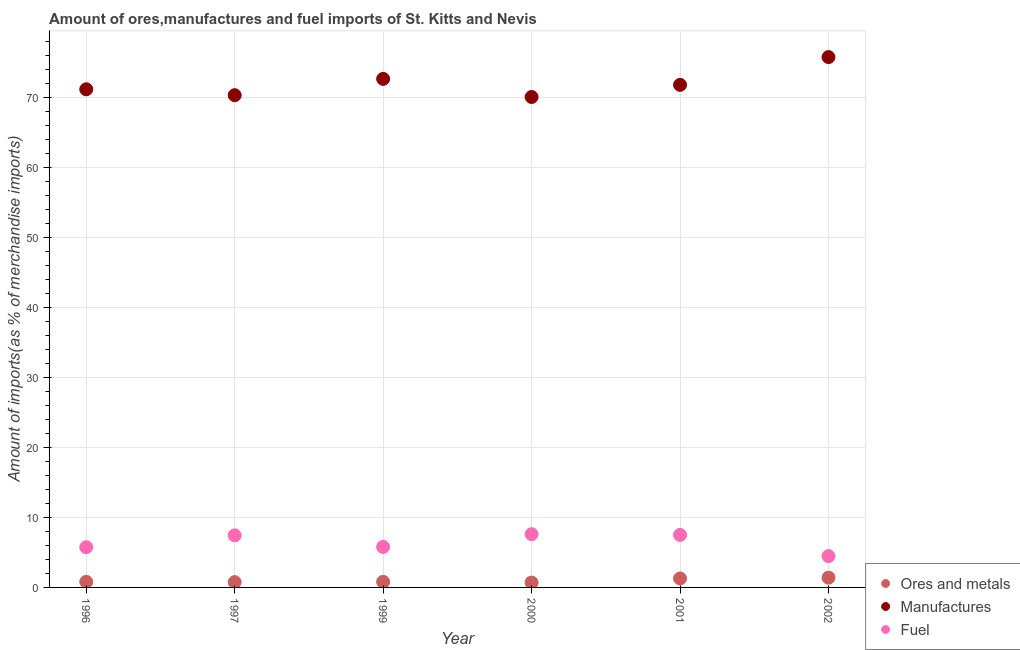How many different coloured dotlines are there?
Your answer should be very brief. 3. Is the number of dotlines equal to the number of legend labels?
Give a very brief answer. Yes. What is the percentage of ores and metals imports in 2002?
Ensure brevity in your answer.  1.39. Across all years, what is the maximum percentage of fuel imports?
Your answer should be very brief. 7.61. Across all years, what is the minimum percentage of ores and metals imports?
Your answer should be very brief. 0.69. In which year was the percentage of ores and metals imports maximum?
Offer a very short reply. 2002. In which year was the percentage of manufactures imports minimum?
Ensure brevity in your answer.  2000. What is the total percentage of ores and metals imports in the graph?
Your response must be concise. 5.73. What is the difference between the percentage of fuel imports in 2001 and that in 2002?
Your answer should be compact. 3.04. What is the difference between the percentage of fuel imports in 1997 and the percentage of manufactures imports in 2000?
Your answer should be compact. -62.66. What is the average percentage of manufactures imports per year?
Offer a terse response. 72.01. In the year 2002, what is the difference between the percentage of manufactures imports and percentage of fuel imports?
Keep it short and to the point. 71.34. In how many years, is the percentage of manufactures imports greater than 76 %?
Provide a succinct answer. 0. What is the ratio of the percentage of manufactures imports in 2001 to that in 2002?
Make the answer very short. 0.95. What is the difference between the highest and the second highest percentage of ores and metals imports?
Provide a succinct answer. 0.11. What is the difference between the highest and the lowest percentage of ores and metals imports?
Provide a succinct answer. 0.7. In how many years, is the percentage of manufactures imports greater than the average percentage of manufactures imports taken over all years?
Provide a short and direct response. 2. Does the percentage of manufactures imports monotonically increase over the years?
Keep it short and to the point. No. How many dotlines are there?
Your response must be concise. 3. How many legend labels are there?
Offer a terse response. 3. How are the legend labels stacked?
Provide a succinct answer. Vertical. What is the title of the graph?
Make the answer very short. Amount of ores,manufactures and fuel imports of St. Kitts and Nevis. Does "Self-employed" appear as one of the legend labels in the graph?
Provide a succinct answer. No. What is the label or title of the X-axis?
Provide a short and direct response. Year. What is the label or title of the Y-axis?
Offer a terse response. Amount of imports(as % of merchandise imports). What is the Amount of imports(as % of merchandise imports) of Ores and metals in 1996?
Your answer should be very brief. 0.8. What is the Amount of imports(as % of merchandise imports) in Manufactures in 1996?
Your answer should be very brief. 71.21. What is the Amount of imports(as % of merchandise imports) of Fuel in 1996?
Ensure brevity in your answer.  5.75. What is the Amount of imports(as % of merchandise imports) in Ores and metals in 1997?
Ensure brevity in your answer.  0.76. What is the Amount of imports(as % of merchandise imports) in Manufactures in 1997?
Offer a very short reply. 70.37. What is the Amount of imports(as % of merchandise imports) in Fuel in 1997?
Provide a short and direct response. 7.45. What is the Amount of imports(as % of merchandise imports) in Ores and metals in 1999?
Your response must be concise. 0.8. What is the Amount of imports(as % of merchandise imports) of Manufactures in 1999?
Give a very brief answer. 72.7. What is the Amount of imports(as % of merchandise imports) of Fuel in 1999?
Ensure brevity in your answer.  5.79. What is the Amount of imports(as % of merchandise imports) of Ores and metals in 2000?
Provide a succinct answer. 0.69. What is the Amount of imports(as % of merchandise imports) in Manufactures in 2000?
Offer a terse response. 70.11. What is the Amount of imports(as % of merchandise imports) in Fuel in 2000?
Provide a succinct answer. 7.61. What is the Amount of imports(as % of merchandise imports) in Ores and metals in 2001?
Make the answer very short. 1.28. What is the Amount of imports(as % of merchandise imports) in Manufactures in 2001?
Keep it short and to the point. 71.85. What is the Amount of imports(as % of merchandise imports) of Fuel in 2001?
Ensure brevity in your answer.  7.51. What is the Amount of imports(as % of merchandise imports) of Ores and metals in 2002?
Ensure brevity in your answer.  1.39. What is the Amount of imports(as % of merchandise imports) in Manufactures in 2002?
Give a very brief answer. 75.82. What is the Amount of imports(as % of merchandise imports) in Fuel in 2002?
Your answer should be compact. 4.47. Across all years, what is the maximum Amount of imports(as % of merchandise imports) of Ores and metals?
Give a very brief answer. 1.39. Across all years, what is the maximum Amount of imports(as % of merchandise imports) in Manufactures?
Ensure brevity in your answer.  75.82. Across all years, what is the maximum Amount of imports(as % of merchandise imports) of Fuel?
Provide a succinct answer. 7.61. Across all years, what is the minimum Amount of imports(as % of merchandise imports) of Ores and metals?
Your answer should be compact. 0.69. Across all years, what is the minimum Amount of imports(as % of merchandise imports) of Manufactures?
Provide a succinct answer. 70.11. Across all years, what is the minimum Amount of imports(as % of merchandise imports) of Fuel?
Keep it short and to the point. 4.47. What is the total Amount of imports(as % of merchandise imports) in Ores and metals in the graph?
Offer a very short reply. 5.73. What is the total Amount of imports(as % of merchandise imports) of Manufactures in the graph?
Provide a short and direct response. 432.06. What is the total Amount of imports(as % of merchandise imports) of Fuel in the graph?
Make the answer very short. 38.58. What is the difference between the Amount of imports(as % of merchandise imports) of Ores and metals in 1996 and that in 1997?
Provide a short and direct response. 0.04. What is the difference between the Amount of imports(as % of merchandise imports) in Manufactures in 1996 and that in 1997?
Offer a terse response. 0.84. What is the difference between the Amount of imports(as % of merchandise imports) of Fuel in 1996 and that in 1997?
Make the answer very short. -1.7. What is the difference between the Amount of imports(as % of merchandise imports) in Ores and metals in 1996 and that in 1999?
Offer a terse response. 0. What is the difference between the Amount of imports(as % of merchandise imports) of Manufactures in 1996 and that in 1999?
Your response must be concise. -1.49. What is the difference between the Amount of imports(as % of merchandise imports) of Fuel in 1996 and that in 1999?
Keep it short and to the point. -0.04. What is the difference between the Amount of imports(as % of merchandise imports) in Ores and metals in 1996 and that in 2000?
Ensure brevity in your answer.  0.11. What is the difference between the Amount of imports(as % of merchandise imports) of Manufactures in 1996 and that in 2000?
Offer a very short reply. 1.1. What is the difference between the Amount of imports(as % of merchandise imports) of Fuel in 1996 and that in 2000?
Make the answer very short. -1.87. What is the difference between the Amount of imports(as % of merchandise imports) in Ores and metals in 1996 and that in 2001?
Keep it short and to the point. -0.48. What is the difference between the Amount of imports(as % of merchandise imports) of Manufactures in 1996 and that in 2001?
Your response must be concise. -0.64. What is the difference between the Amount of imports(as % of merchandise imports) in Fuel in 1996 and that in 2001?
Give a very brief answer. -1.76. What is the difference between the Amount of imports(as % of merchandise imports) of Ores and metals in 1996 and that in 2002?
Offer a very short reply. -0.59. What is the difference between the Amount of imports(as % of merchandise imports) of Manufactures in 1996 and that in 2002?
Ensure brevity in your answer.  -4.6. What is the difference between the Amount of imports(as % of merchandise imports) in Fuel in 1996 and that in 2002?
Make the answer very short. 1.27. What is the difference between the Amount of imports(as % of merchandise imports) in Ores and metals in 1997 and that in 1999?
Your answer should be very brief. -0.04. What is the difference between the Amount of imports(as % of merchandise imports) in Manufactures in 1997 and that in 1999?
Offer a terse response. -2.33. What is the difference between the Amount of imports(as % of merchandise imports) in Fuel in 1997 and that in 1999?
Provide a short and direct response. 1.66. What is the difference between the Amount of imports(as % of merchandise imports) in Ores and metals in 1997 and that in 2000?
Give a very brief answer. 0.07. What is the difference between the Amount of imports(as % of merchandise imports) of Manufactures in 1997 and that in 2000?
Ensure brevity in your answer.  0.26. What is the difference between the Amount of imports(as % of merchandise imports) of Fuel in 1997 and that in 2000?
Provide a succinct answer. -0.16. What is the difference between the Amount of imports(as % of merchandise imports) of Ores and metals in 1997 and that in 2001?
Your response must be concise. -0.52. What is the difference between the Amount of imports(as % of merchandise imports) in Manufactures in 1997 and that in 2001?
Offer a terse response. -1.48. What is the difference between the Amount of imports(as % of merchandise imports) of Fuel in 1997 and that in 2001?
Give a very brief answer. -0.06. What is the difference between the Amount of imports(as % of merchandise imports) in Ores and metals in 1997 and that in 2002?
Offer a terse response. -0.63. What is the difference between the Amount of imports(as % of merchandise imports) in Manufactures in 1997 and that in 2002?
Your answer should be compact. -5.45. What is the difference between the Amount of imports(as % of merchandise imports) of Fuel in 1997 and that in 2002?
Keep it short and to the point. 2.98. What is the difference between the Amount of imports(as % of merchandise imports) of Ores and metals in 1999 and that in 2000?
Offer a terse response. 0.11. What is the difference between the Amount of imports(as % of merchandise imports) of Manufactures in 1999 and that in 2000?
Provide a short and direct response. 2.59. What is the difference between the Amount of imports(as % of merchandise imports) of Fuel in 1999 and that in 2000?
Ensure brevity in your answer.  -1.83. What is the difference between the Amount of imports(as % of merchandise imports) of Ores and metals in 1999 and that in 2001?
Offer a very short reply. -0.48. What is the difference between the Amount of imports(as % of merchandise imports) in Manufactures in 1999 and that in 2001?
Your answer should be very brief. 0.85. What is the difference between the Amount of imports(as % of merchandise imports) of Fuel in 1999 and that in 2001?
Your answer should be very brief. -1.72. What is the difference between the Amount of imports(as % of merchandise imports) of Ores and metals in 1999 and that in 2002?
Provide a short and direct response. -0.59. What is the difference between the Amount of imports(as % of merchandise imports) of Manufactures in 1999 and that in 2002?
Offer a very short reply. -3.11. What is the difference between the Amount of imports(as % of merchandise imports) of Fuel in 1999 and that in 2002?
Your answer should be compact. 1.31. What is the difference between the Amount of imports(as % of merchandise imports) of Ores and metals in 2000 and that in 2001?
Keep it short and to the point. -0.59. What is the difference between the Amount of imports(as % of merchandise imports) in Manufactures in 2000 and that in 2001?
Give a very brief answer. -1.74. What is the difference between the Amount of imports(as % of merchandise imports) in Fuel in 2000 and that in 2001?
Your answer should be very brief. 0.1. What is the difference between the Amount of imports(as % of merchandise imports) in Ores and metals in 2000 and that in 2002?
Your answer should be very brief. -0.7. What is the difference between the Amount of imports(as % of merchandise imports) in Manufactures in 2000 and that in 2002?
Offer a terse response. -5.7. What is the difference between the Amount of imports(as % of merchandise imports) of Fuel in 2000 and that in 2002?
Ensure brevity in your answer.  3.14. What is the difference between the Amount of imports(as % of merchandise imports) of Ores and metals in 2001 and that in 2002?
Keep it short and to the point. -0.11. What is the difference between the Amount of imports(as % of merchandise imports) of Manufactures in 2001 and that in 2002?
Ensure brevity in your answer.  -3.97. What is the difference between the Amount of imports(as % of merchandise imports) in Fuel in 2001 and that in 2002?
Give a very brief answer. 3.04. What is the difference between the Amount of imports(as % of merchandise imports) of Ores and metals in 1996 and the Amount of imports(as % of merchandise imports) of Manufactures in 1997?
Offer a very short reply. -69.57. What is the difference between the Amount of imports(as % of merchandise imports) of Ores and metals in 1996 and the Amount of imports(as % of merchandise imports) of Fuel in 1997?
Offer a very short reply. -6.65. What is the difference between the Amount of imports(as % of merchandise imports) in Manufactures in 1996 and the Amount of imports(as % of merchandise imports) in Fuel in 1997?
Provide a succinct answer. 63.76. What is the difference between the Amount of imports(as % of merchandise imports) in Ores and metals in 1996 and the Amount of imports(as % of merchandise imports) in Manufactures in 1999?
Offer a very short reply. -71.9. What is the difference between the Amount of imports(as % of merchandise imports) of Ores and metals in 1996 and the Amount of imports(as % of merchandise imports) of Fuel in 1999?
Ensure brevity in your answer.  -4.98. What is the difference between the Amount of imports(as % of merchandise imports) in Manufactures in 1996 and the Amount of imports(as % of merchandise imports) in Fuel in 1999?
Your response must be concise. 65.43. What is the difference between the Amount of imports(as % of merchandise imports) of Ores and metals in 1996 and the Amount of imports(as % of merchandise imports) of Manufactures in 2000?
Provide a short and direct response. -69.31. What is the difference between the Amount of imports(as % of merchandise imports) of Ores and metals in 1996 and the Amount of imports(as % of merchandise imports) of Fuel in 2000?
Your answer should be very brief. -6.81. What is the difference between the Amount of imports(as % of merchandise imports) in Manufactures in 1996 and the Amount of imports(as % of merchandise imports) in Fuel in 2000?
Your answer should be compact. 63.6. What is the difference between the Amount of imports(as % of merchandise imports) of Ores and metals in 1996 and the Amount of imports(as % of merchandise imports) of Manufactures in 2001?
Your answer should be compact. -71.05. What is the difference between the Amount of imports(as % of merchandise imports) of Ores and metals in 1996 and the Amount of imports(as % of merchandise imports) of Fuel in 2001?
Your answer should be very brief. -6.71. What is the difference between the Amount of imports(as % of merchandise imports) in Manufactures in 1996 and the Amount of imports(as % of merchandise imports) in Fuel in 2001?
Offer a very short reply. 63.7. What is the difference between the Amount of imports(as % of merchandise imports) in Ores and metals in 1996 and the Amount of imports(as % of merchandise imports) in Manufactures in 2002?
Provide a succinct answer. -75.01. What is the difference between the Amount of imports(as % of merchandise imports) in Ores and metals in 1996 and the Amount of imports(as % of merchandise imports) in Fuel in 2002?
Offer a very short reply. -3.67. What is the difference between the Amount of imports(as % of merchandise imports) of Manufactures in 1996 and the Amount of imports(as % of merchandise imports) of Fuel in 2002?
Keep it short and to the point. 66.74. What is the difference between the Amount of imports(as % of merchandise imports) of Ores and metals in 1997 and the Amount of imports(as % of merchandise imports) of Manufactures in 1999?
Provide a short and direct response. -71.94. What is the difference between the Amount of imports(as % of merchandise imports) in Ores and metals in 1997 and the Amount of imports(as % of merchandise imports) in Fuel in 1999?
Provide a succinct answer. -5.03. What is the difference between the Amount of imports(as % of merchandise imports) of Manufactures in 1997 and the Amount of imports(as % of merchandise imports) of Fuel in 1999?
Your answer should be compact. 64.58. What is the difference between the Amount of imports(as % of merchandise imports) of Ores and metals in 1997 and the Amount of imports(as % of merchandise imports) of Manufactures in 2000?
Keep it short and to the point. -69.35. What is the difference between the Amount of imports(as % of merchandise imports) of Ores and metals in 1997 and the Amount of imports(as % of merchandise imports) of Fuel in 2000?
Give a very brief answer. -6.85. What is the difference between the Amount of imports(as % of merchandise imports) in Manufactures in 1997 and the Amount of imports(as % of merchandise imports) in Fuel in 2000?
Offer a terse response. 62.76. What is the difference between the Amount of imports(as % of merchandise imports) in Ores and metals in 1997 and the Amount of imports(as % of merchandise imports) in Manufactures in 2001?
Your answer should be very brief. -71.09. What is the difference between the Amount of imports(as % of merchandise imports) of Ores and metals in 1997 and the Amount of imports(as % of merchandise imports) of Fuel in 2001?
Offer a very short reply. -6.75. What is the difference between the Amount of imports(as % of merchandise imports) of Manufactures in 1997 and the Amount of imports(as % of merchandise imports) of Fuel in 2001?
Your answer should be compact. 62.86. What is the difference between the Amount of imports(as % of merchandise imports) in Ores and metals in 1997 and the Amount of imports(as % of merchandise imports) in Manufactures in 2002?
Make the answer very short. -75.05. What is the difference between the Amount of imports(as % of merchandise imports) in Ores and metals in 1997 and the Amount of imports(as % of merchandise imports) in Fuel in 2002?
Your answer should be very brief. -3.71. What is the difference between the Amount of imports(as % of merchandise imports) of Manufactures in 1997 and the Amount of imports(as % of merchandise imports) of Fuel in 2002?
Your response must be concise. 65.9. What is the difference between the Amount of imports(as % of merchandise imports) of Ores and metals in 1999 and the Amount of imports(as % of merchandise imports) of Manufactures in 2000?
Offer a very short reply. -69.31. What is the difference between the Amount of imports(as % of merchandise imports) of Ores and metals in 1999 and the Amount of imports(as % of merchandise imports) of Fuel in 2000?
Your answer should be very brief. -6.81. What is the difference between the Amount of imports(as % of merchandise imports) in Manufactures in 1999 and the Amount of imports(as % of merchandise imports) in Fuel in 2000?
Provide a succinct answer. 65.09. What is the difference between the Amount of imports(as % of merchandise imports) in Ores and metals in 1999 and the Amount of imports(as % of merchandise imports) in Manufactures in 2001?
Your answer should be very brief. -71.05. What is the difference between the Amount of imports(as % of merchandise imports) of Ores and metals in 1999 and the Amount of imports(as % of merchandise imports) of Fuel in 2001?
Provide a succinct answer. -6.71. What is the difference between the Amount of imports(as % of merchandise imports) in Manufactures in 1999 and the Amount of imports(as % of merchandise imports) in Fuel in 2001?
Your answer should be very brief. 65.19. What is the difference between the Amount of imports(as % of merchandise imports) in Ores and metals in 1999 and the Amount of imports(as % of merchandise imports) in Manufactures in 2002?
Keep it short and to the point. -75.01. What is the difference between the Amount of imports(as % of merchandise imports) in Ores and metals in 1999 and the Amount of imports(as % of merchandise imports) in Fuel in 2002?
Ensure brevity in your answer.  -3.67. What is the difference between the Amount of imports(as % of merchandise imports) of Manufactures in 1999 and the Amount of imports(as % of merchandise imports) of Fuel in 2002?
Offer a very short reply. 68.23. What is the difference between the Amount of imports(as % of merchandise imports) in Ores and metals in 2000 and the Amount of imports(as % of merchandise imports) in Manufactures in 2001?
Provide a succinct answer. -71.16. What is the difference between the Amount of imports(as % of merchandise imports) in Ores and metals in 2000 and the Amount of imports(as % of merchandise imports) in Fuel in 2001?
Your response must be concise. -6.82. What is the difference between the Amount of imports(as % of merchandise imports) in Manufactures in 2000 and the Amount of imports(as % of merchandise imports) in Fuel in 2001?
Make the answer very short. 62.6. What is the difference between the Amount of imports(as % of merchandise imports) in Ores and metals in 2000 and the Amount of imports(as % of merchandise imports) in Manufactures in 2002?
Offer a terse response. -75.12. What is the difference between the Amount of imports(as % of merchandise imports) of Ores and metals in 2000 and the Amount of imports(as % of merchandise imports) of Fuel in 2002?
Keep it short and to the point. -3.78. What is the difference between the Amount of imports(as % of merchandise imports) in Manufactures in 2000 and the Amount of imports(as % of merchandise imports) in Fuel in 2002?
Offer a terse response. 65.64. What is the difference between the Amount of imports(as % of merchandise imports) in Ores and metals in 2001 and the Amount of imports(as % of merchandise imports) in Manufactures in 2002?
Offer a very short reply. -74.53. What is the difference between the Amount of imports(as % of merchandise imports) of Ores and metals in 2001 and the Amount of imports(as % of merchandise imports) of Fuel in 2002?
Keep it short and to the point. -3.19. What is the difference between the Amount of imports(as % of merchandise imports) in Manufactures in 2001 and the Amount of imports(as % of merchandise imports) in Fuel in 2002?
Your answer should be compact. 67.38. What is the average Amount of imports(as % of merchandise imports) in Ores and metals per year?
Provide a short and direct response. 0.96. What is the average Amount of imports(as % of merchandise imports) of Manufactures per year?
Your response must be concise. 72.01. What is the average Amount of imports(as % of merchandise imports) in Fuel per year?
Give a very brief answer. 6.43. In the year 1996, what is the difference between the Amount of imports(as % of merchandise imports) of Ores and metals and Amount of imports(as % of merchandise imports) of Manufactures?
Your response must be concise. -70.41. In the year 1996, what is the difference between the Amount of imports(as % of merchandise imports) of Ores and metals and Amount of imports(as % of merchandise imports) of Fuel?
Your response must be concise. -4.95. In the year 1996, what is the difference between the Amount of imports(as % of merchandise imports) of Manufactures and Amount of imports(as % of merchandise imports) of Fuel?
Ensure brevity in your answer.  65.46. In the year 1997, what is the difference between the Amount of imports(as % of merchandise imports) in Ores and metals and Amount of imports(as % of merchandise imports) in Manufactures?
Your answer should be very brief. -69.61. In the year 1997, what is the difference between the Amount of imports(as % of merchandise imports) of Ores and metals and Amount of imports(as % of merchandise imports) of Fuel?
Offer a very short reply. -6.69. In the year 1997, what is the difference between the Amount of imports(as % of merchandise imports) of Manufactures and Amount of imports(as % of merchandise imports) of Fuel?
Make the answer very short. 62.92. In the year 1999, what is the difference between the Amount of imports(as % of merchandise imports) in Ores and metals and Amount of imports(as % of merchandise imports) in Manufactures?
Make the answer very short. -71.9. In the year 1999, what is the difference between the Amount of imports(as % of merchandise imports) in Ores and metals and Amount of imports(as % of merchandise imports) in Fuel?
Give a very brief answer. -4.99. In the year 1999, what is the difference between the Amount of imports(as % of merchandise imports) in Manufactures and Amount of imports(as % of merchandise imports) in Fuel?
Keep it short and to the point. 66.92. In the year 2000, what is the difference between the Amount of imports(as % of merchandise imports) of Ores and metals and Amount of imports(as % of merchandise imports) of Manufactures?
Provide a succinct answer. -69.42. In the year 2000, what is the difference between the Amount of imports(as % of merchandise imports) of Ores and metals and Amount of imports(as % of merchandise imports) of Fuel?
Ensure brevity in your answer.  -6.92. In the year 2000, what is the difference between the Amount of imports(as % of merchandise imports) in Manufactures and Amount of imports(as % of merchandise imports) in Fuel?
Offer a very short reply. 62.5. In the year 2001, what is the difference between the Amount of imports(as % of merchandise imports) in Ores and metals and Amount of imports(as % of merchandise imports) in Manufactures?
Provide a succinct answer. -70.57. In the year 2001, what is the difference between the Amount of imports(as % of merchandise imports) of Ores and metals and Amount of imports(as % of merchandise imports) of Fuel?
Your answer should be compact. -6.23. In the year 2001, what is the difference between the Amount of imports(as % of merchandise imports) in Manufactures and Amount of imports(as % of merchandise imports) in Fuel?
Your response must be concise. 64.34. In the year 2002, what is the difference between the Amount of imports(as % of merchandise imports) in Ores and metals and Amount of imports(as % of merchandise imports) in Manufactures?
Provide a succinct answer. -74.42. In the year 2002, what is the difference between the Amount of imports(as % of merchandise imports) of Ores and metals and Amount of imports(as % of merchandise imports) of Fuel?
Provide a succinct answer. -3.08. In the year 2002, what is the difference between the Amount of imports(as % of merchandise imports) in Manufactures and Amount of imports(as % of merchandise imports) in Fuel?
Keep it short and to the point. 71.34. What is the ratio of the Amount of imports(as % of merchandise imports) of Ores and metals in 1996 to that in 1997?
Give a very brief answer. 1.05. What is the ratio of the Amount of imports(as % of merchandise imports) in Fuel in 1996 to that in 1997?
Offer a very short reply. 0.77. What is the ratio of the Amount of imports(as % of merchandise imports) in Manufactures in 1996 to that in 1999?
Make the answer very short. 0.98. What is the ratio of the Amount of imports(as % of merchandise imports) of Fuel in 1996 to that in 1999?
Provide a succinct answer. 0.99. What is the ratio of the Amount of imports(as % of merchandise imports) in Ores and metals in 1996 to that in 2000?
Provide a short and direct response. 1.16. What is the ratio of the Amount of imports(as % of merchandise imports) in Manufactures in 1996 to that in 2000?
Provide a short and direct response. 1.02. What is the ratio of the Amount of imports(as % of merchandise imports) in Fuel in 1996 to that in 2000?
Provide a short and direct response. 0.76. What is the ratio of the Amount of imports(as % of merchandise imports) of Ores and metals in 1996 to that in 2001?
Make the answer very short. 0.62. What is the ratio of the Amount of imports(as % of merchandise imports) of Manufactures in 1996 to that in 2001?
Give a very brief answer. 0.99. What is the ratio of the Amount of imports(as % of merchandise imports) of Fuel in 1996 to that in 2001?
Your answer should be compact. 0.77. What is the ratio of the Amount of imports(as % of merchandise imports) in Ores and metals in 1996 to that in 2002?
Provide a short and direct response. 0.57. What is the ratio of the Amount of imports(as % of merchandise imports) in Manufactures in 1996 to that in 2002?
Your answer should be very brief. 0.94. What is the ratio of the Amount of imports(as % of merchandise imports) in Fuel in 1996 to that in 2002?
Your answer should be very brief. 1.28. What is the ratio of the Amount of imports(as % of merchandise imports) in Ores and metals in 1997 to that in 1999?
Keep it short and to the point. 0.95. What is the ratio of the Amount of imports(as % of merchandise imports) of Manufactures in 1997 to that in 1999?
Your answer should be compact. 0.97. What is the ratio of the Amount of imports(as % of merchandise imports) of Fuel in 1997 to that in 1999?
Provide a succinct answer. 1.29. What is the ratio of the Amount of imports(as % of merchandise imports) in Ores and metals in 1997 to that in 2000?
Give a very brief answer. 1.1. What is the ratio of the Amount of imports(as % of merchandise imports) in Manufactures in 1997 to that in 2000?
Ensure brevity in your answer.  1. What is the ratio of the Amount of imports(as % of merchandise imports) of Fuel in 1997 to that in 2000?
Offer a terse response. 0.98. What is the ratio of the Amount of imports(as % of merchandise imports) in Ores and metals in 1997 to that in 2001?
Offer a terse response. 0.59. What is the ratio of the Amount of imports(as % of merchandise imports) of Manufactures in 1997 to that in 2001?
Make the answer very short. 0.98. What is the ratio of the Amount of imports(as % of merchandise imports) in Ores and metals in 1997 to that in 2002?
Offer a terse response. 0.55. What is the ratio of the Amount of imports(as % of merchandise imports) of Manufactures in 1997 to that in 2002?
Provide a succinct answer. 0.93. What is the ratio of the Amount of imports(as % of merchandise imports) of Fuel in 1997 to that in 2002?
Your response must be concise. 1.67. What is the ratio of the Amount of imports(as % of merchandise imports) in Ores and metals in 1999 to that in 2000?
Give a very brief answer. 1.16. What is the ratio of the Amount of imports(as % of merchandise imports) of Manufactures in 1999 to that in 2000?
Provide a succinct answer. 1.04. What is the ratio of the Amount of imports(as % of merchandise imports) of Fuel in 1999 to that in 2000?
Ensure brevity in your answer.  0.76. What is the ratio of the Amount of imports(as % of merchandise imports) in Ores and metals in 1999 to that in 2001?
Give a very brief answer. 0.62. What is the ratio of the Amount of imports(as % of merchandise imports) in Manufactures in 1999 to that in 2001?
Your response must be concise. 1.01. What is the ratio of the Amount of imports(as % of merchandise imports) of Fuel in 1999 to that in 2001?
Your response must be concise. 0.77. What is the ratio of the Amount of imports(as % of merchandise imports) of Ores and metals in 1999 to that in 2002?
Offer a very short reply. 0.57. What is the ratio of the Amount of imports(as % of merchandise imports) of Manufactures in 1999 to that in 2002?
Offer a very short reply. 0.96. What is the ratio of the Amount of imports(as % of merchandise imports) of Fuel in 1999 to that in 2002?
Offer a terse response. 1.29. What is the ratio of the Amount of imports(as % of merchandise imports) of Ores and metals in 2000 to that in 2001?
Make the answer very short. 0.54. What is the ratio of the Amount of imports(as % of merchandise imports) of Manufactures in 2000 to that in 2001?
Your answer should be very brief. 0.98. What is the ratio of the Amount of imports(as % of merchandise imports) of Fuel in 2000 to that in 2001?
Your answer should be compact. 1.01. What is the ratio of the Amount of imports(as % of merchandise imports) in Ores and metals in 2000 to that in 2002?
Make the answer very short. 0.5. What is the ratio of the Amount of imports(as % of merchandise imports) in Manufactures in 2000 to that in 2002?
Provide a short and direct response. 0.92. What is the ratio of the Amount of imports(as % of merchandise imports) of Fuel in 2000 to that in 2002?
Your response must be concise. 1.7. What is the ratio of the Amount of imports(as % of merchandise imports) in Ores and metals in 2001 to that in 2002?
Offer a very short reply. 0.92. What is the ratio of the Amount of imports(as % of merchandise imports) of Manufactures in 2001 to that in 2002?
Keep it short and to the point. 0.95. What is the ratio of the Amount of imports(as % of merchandise imports) of Fuel in 2001 to that in 2002?
Make the answer very short. 1.68. What is the difference between the highest and the second highest Amount of imports(as % of merchandise imports) in Ores and metals?
Keep it short and to the point. 0.11. What is the difference between the highest and the second highest Amount of imports(as % of merchandise imports) in Manufactures?
Ensure brevity in your answer.  3.11. What is the difference between the highest and the second highest Amount of imports(as % of merchandise imports) of Fuel?
Your response must be concise. 0.1. What is the difference between the highest and the lowest Amount of imports(as % of merchandise imports) in Ores and metals?
Offer a very short reply. 0.7. What is the difference between the highest and the lowest Amount of imports(as % of merchandise imports) of Manufactures?
Your answer should be very brief. 5.7. What is the difference between the highest and the lowest Amount of imports(as % of merchandise imports) of Fuel?
Offer a very short reply. 3.14. 